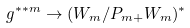Convert formula to latex. <formula><loc_0><loc_0><loc_500><loc_500>\ g ^ { * * m } \to ( W _ { m } / P _ { m + } W _ { m } ) ^ { * }</formula> 